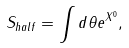<formula> <loc_0><loc_0><loc_500><loc_500>S _ { h a l f } = \int d \theta e ^ { X ^ { 0 } } ,</formula> 